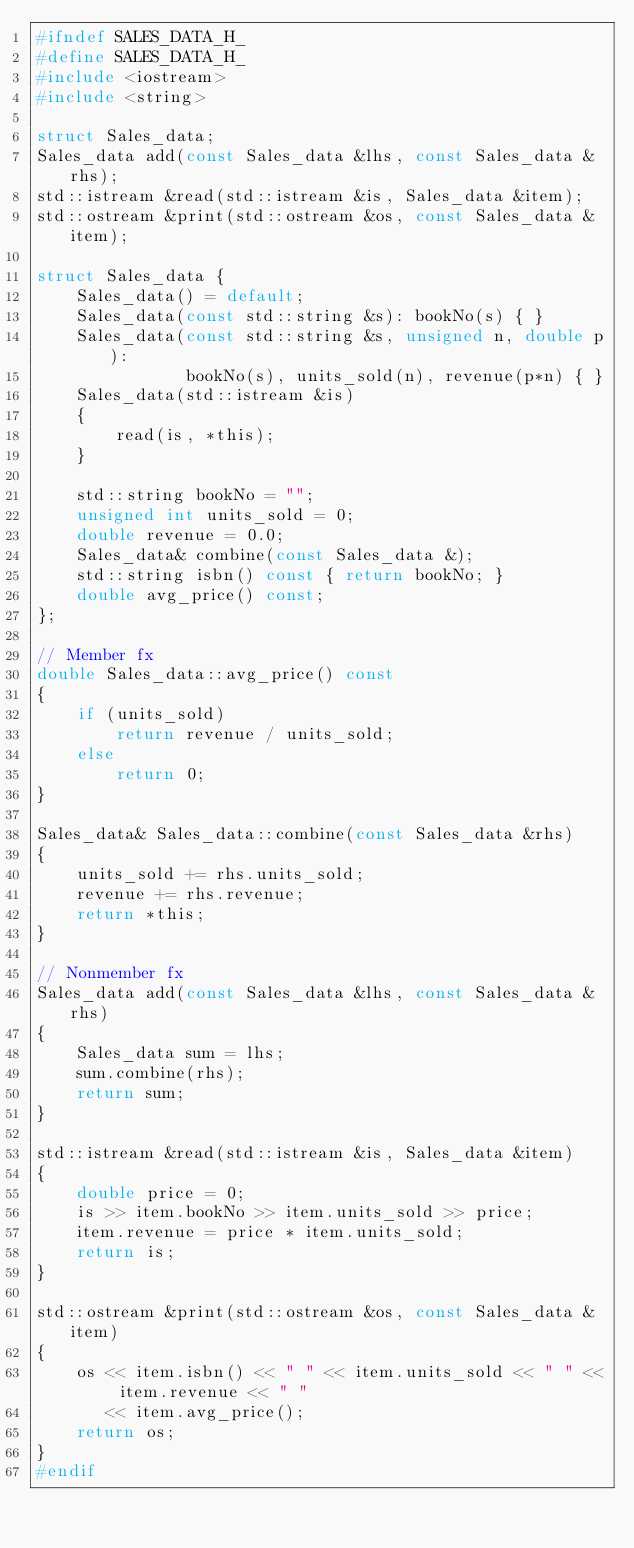Convert code to text. <code><loc_0><loc_0><loc_500><loc_500><_C_>#ifndef SALES_DATA_H_
#define SALES_DATA_H_
#include <iostream>
#include <string>

struct Sales_data;
Sales_data add(const Sales_data &lhs, const Sales_data &rhs);
std::istream &read(std::istream &is, Sales_data &item);
std::ostream &print(std::ostream &os, const Sales_data &item);

struct Sales_data {
    Sales_data() = default;
    Sales_data(const std::string &s): bookNo(s) { }
    Sales_data(const std::string &s, unsigned n, double p):
               bookNo(s), units_sold(n), revenue(p*n) { }
    Sales_data(std::istream &is)
    {
        read(is, *this);
    }

    std::string bookNo = "";
    unsigned int units_sold = 0;
    double revenue = 0.0;
    Sales_data& combine(const Sales_data &);
    std::string isbn() const { return bookNo; }
    double avg_price() const;
};

// Member fx
double Sales_data::avg_price() const
{
    if (units_sold)
        return revenue / units_sold;
    else
        return 0;
}

Sales_data& Sales_data::combine(const Sales_data &rhs)
{
    units_sold += rhs.units_sold;
    revenue += rhs.revenue;
    return *this;
}

// Nonmember fx
Sales_data add(const Sales_data &lhs, const Sales_data &rhs)
{
    Sales_data sum = lhs;
    sum.combine(rhs);
    return sum;
}

std::istream &read(std::istream &is, Sales_data &item)
{
    double price = 0;
    is >> item.bookNo >> item.units_sold >> price;
    item.revenue = price * item.units_sold;
    return is;
}

std::ostream &print(std::ostream &os, const Sales_data &item)
{
    os << item.isbn() << " " << item.units_sold << " " << item.revenue << " "
       << item.avg_price();
    return os;
}
#endif
</code> 